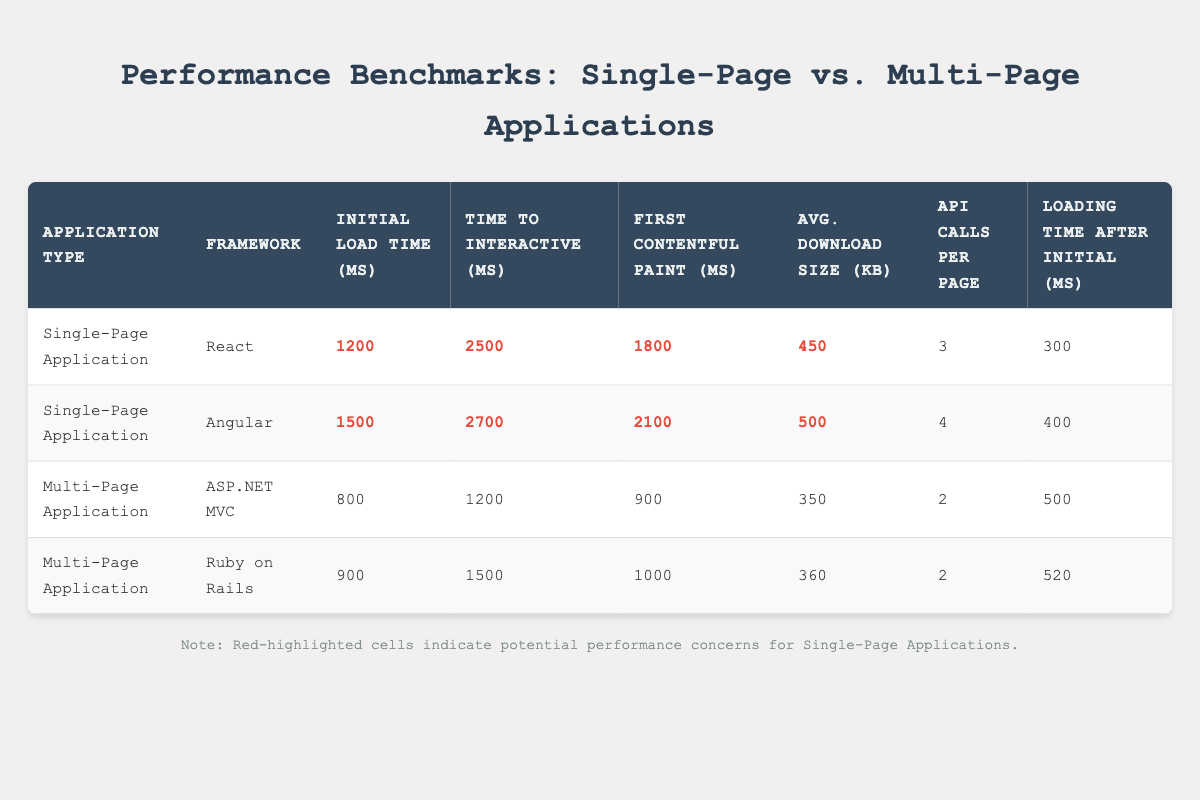What is the initial load time for the React Single-Page Application? The table shows the initial load time for the React Single-Page Application is 1200 ms.
Answer: 1200 ms Which framework has the highest average download size? Comparing the average download sizes in the table, Angular has an average download size of 500 KB, which is higher than the others (React: 450 KB, ASP.NET MVC: 350 KB, Ruby on Rails: 360 KB).
Answer: Angular What is the time to interactive for ASP.NET MVC? The table indicates that the time to interactive for the ASP.NET MVC framework is 1200 ms.
Answer: 1200 ms Which type of application typically has a higher time to interactive, Single-Page Applications or Multi-Page Applications? Observing the table, Single-Page Applications (React: 2500 ms, Angular: 2700 ms) have a higher time to interactive than Multi-Page Applications (ASP.NET MVC: 1200 ms, Ruby on Rails: 1500 ms), indicating that SPAs generally take longer to become interactive.
Answer: Single-Page Applications What is the difference in initial load time between the two types of applications? The average initial load time for Single-Page Applications is calculated as (1200 + 1500) / 2 = 1350 ms, while for Multi-Page Applications, it is (800 + 900) / 2 = 850 ms. Thus, the difference is 1350 - 850 = 500 ms.
Answer: 500 ms Is the loading time after initial loading higher for Single-Page Applications compared to Multi-Page Applications? From the table, the loading time after the initial load is 300 ms for React and 400 ms for Angular, while for ASP.NET MVC it's 500 ms and for Ruby on Rails it's 520 ms. In fact, SPAs show lower loading times after initial load compared to MPAs.
Answer: No Which framework has the fastest First Contentful Paint? The table shows that ASP.NET MVC has the fastest First Contentful Paint at 900 ms, while the SPAs have higher values (React: 1800 ms, Angular: 2100 ms).
Answer: ASP.NET MVC What are the average API calls per page for Single-Page Applications, and how do they compare to Multi-Page Applications? The average API calls per page for Single-Page Applications are (3 + 4) / 2 = 3.5, while Multi-Page Applications have an average of (2 + 2) / 2 = 2. So, SPAs have more API calls compared to MPAs.
Answer: 3.5 Can you confirm if Ruby on Rails requires more API calls per page than React? Referring to the table, both Ruby on Rails and React have API calls per page values of 2 and 3, respectively. Since 3 is greater than 2, Ruby on Rails does not require more API calls than React.
Answer: No 